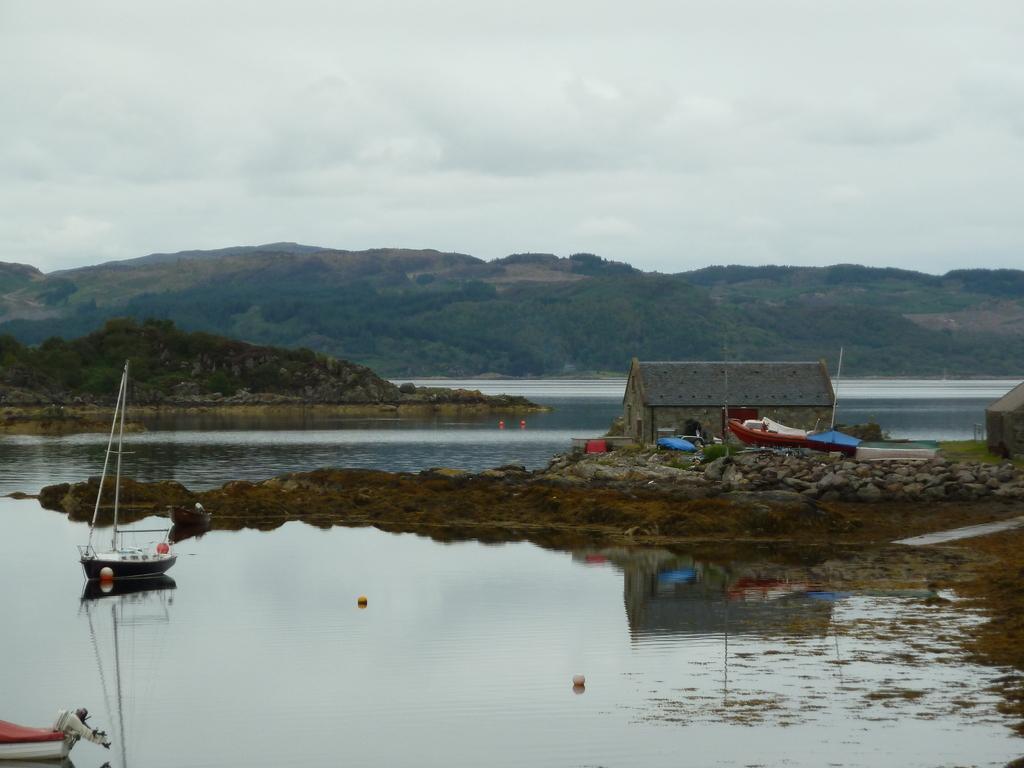Describe this image in one or two sentences. This image consists of water. In the front, there is a small house. There are small boats in the water. In the background, there are mountains covered with plants. To the top, there are clouds in the sky. 